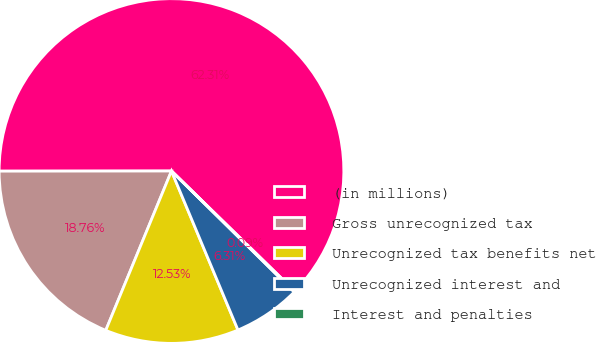Convert chart to OTSL. <chart><loc_0><loc_0><loc_500><loc_500><pie_chart><fcel>(in millions)<fcel>Gross unrecognized tax<fcel>Unrecognized tax benefits net<fcel>Unrecognized interest and<fcel>Interest and penalties<nl><fcel>62.3%<fcel>18.76%<fcel>12.53%<fcel>6.31%<fcel>0.09%<nl></chart> 